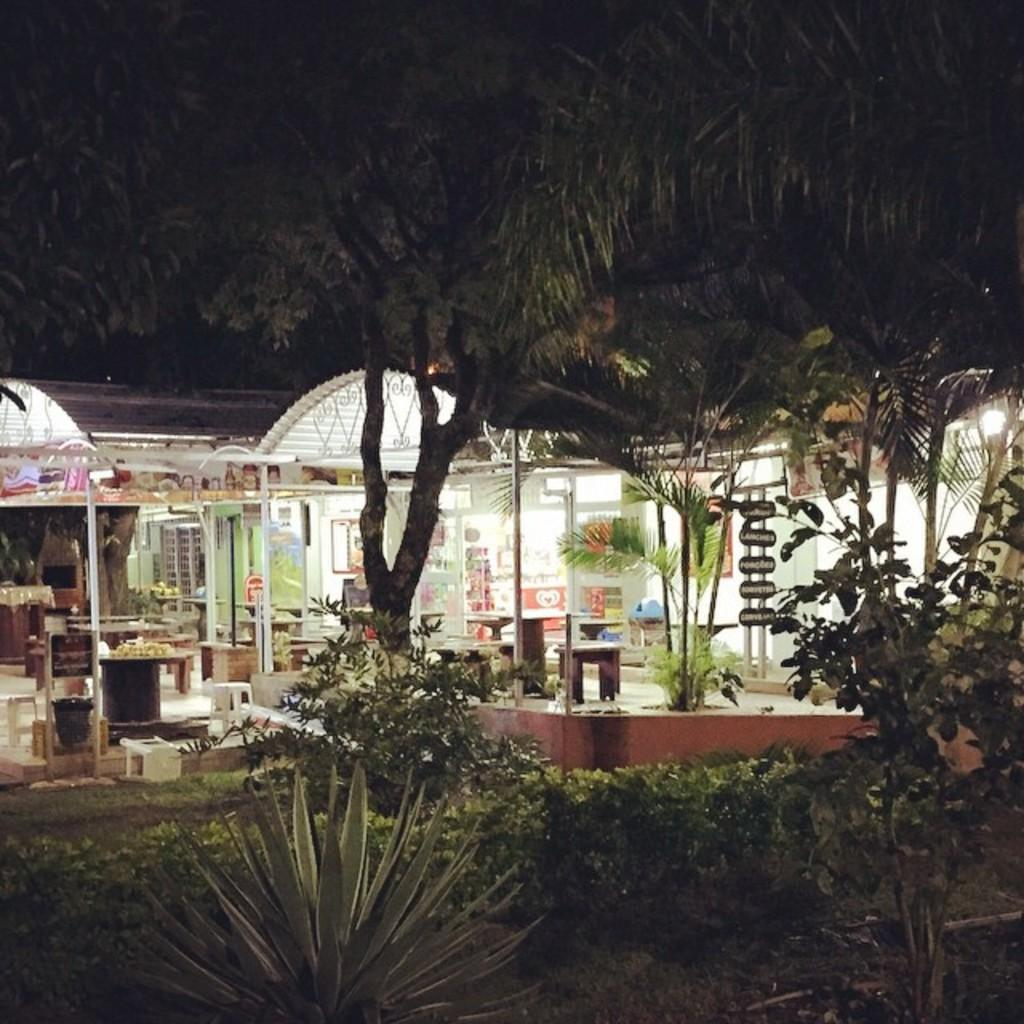What type of vegetation can be seen in the image? There are plants and many trees in the image. What structure is visible in the background of the image? There is a shed in the background of the image. What is the shed made of? The shed has boards. What furniture is present inside the shed? There are tables and benches in the shed. What lighting is available inside the shed? There are lights in the shed. What type of grain is being discussed in the image? There is no discussion or grain present in the image. What color is the coat hanging on the wall in the image? There is no coat present in the image. 